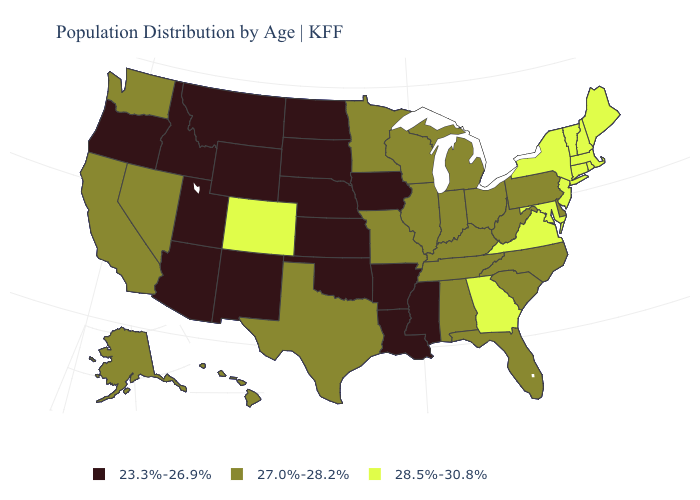Name the states that have a value in the range 28.5%-30.8%?
Keep it brief. Colorado, Connecticut, Georgia, Maine, Maryland, Massachusetts, New Hampshire, New Jersey, New York, Rhode Island, Vermont, Virginia. Is the legend a continuous bar?
Short answer required. No. Name the states that have a value in the range 28.5%-30.8%?
Short answer required. Colorado, Connecticut, Georgia, Maine, Maryland, Massachusetts, New Hampshire, New Jersey, New York, Rhode Island, Vermont, Virginia. Which states have the lowest value in the USA?
Short answer required. Arizona, Arkansas, Idaho, Iowa, Kansas, Louisiana, Mississippi, Montana, Nebraska, New Mexico, North Dakota, Oklahoma, Oregon, South Dakota, Utah, Wyoming. What is the lowest value in states that border Rhode Island?
Concise answer only. 28.5%-30.8%. What is the lowest value in the Northeast?
Be succinct. 27.0%-28.2%. What is the highest value in states that border Massachusetts?
Write a very short answer. 28.5%-30.8%. What is the value of Idaho?
Quick response, please. 23.3%-26.9%. Does Virginia have a higher value than New Hampshire?
Answer briefly. No. Which states hav the highest value in the South?
Answer briefly. Georgia, Maryland, Virginia. Is the legend a continuous bar?
Short answer required. No. Among the states that border Colorado , which have the highest value?
Keep it brief. Arizona, Kansas, Nebraska, New Mexico, Oklahoma, Utah, Wyoming. What is the lowest value in states that border New Hampshire?
Short answer required. 28.5%-30.8%. What is the highest value in the USA?
Concise answer only. 28.5%-30.8%. What is the value of South Carolina?
Short answer required. 27.0%-28.2%. 